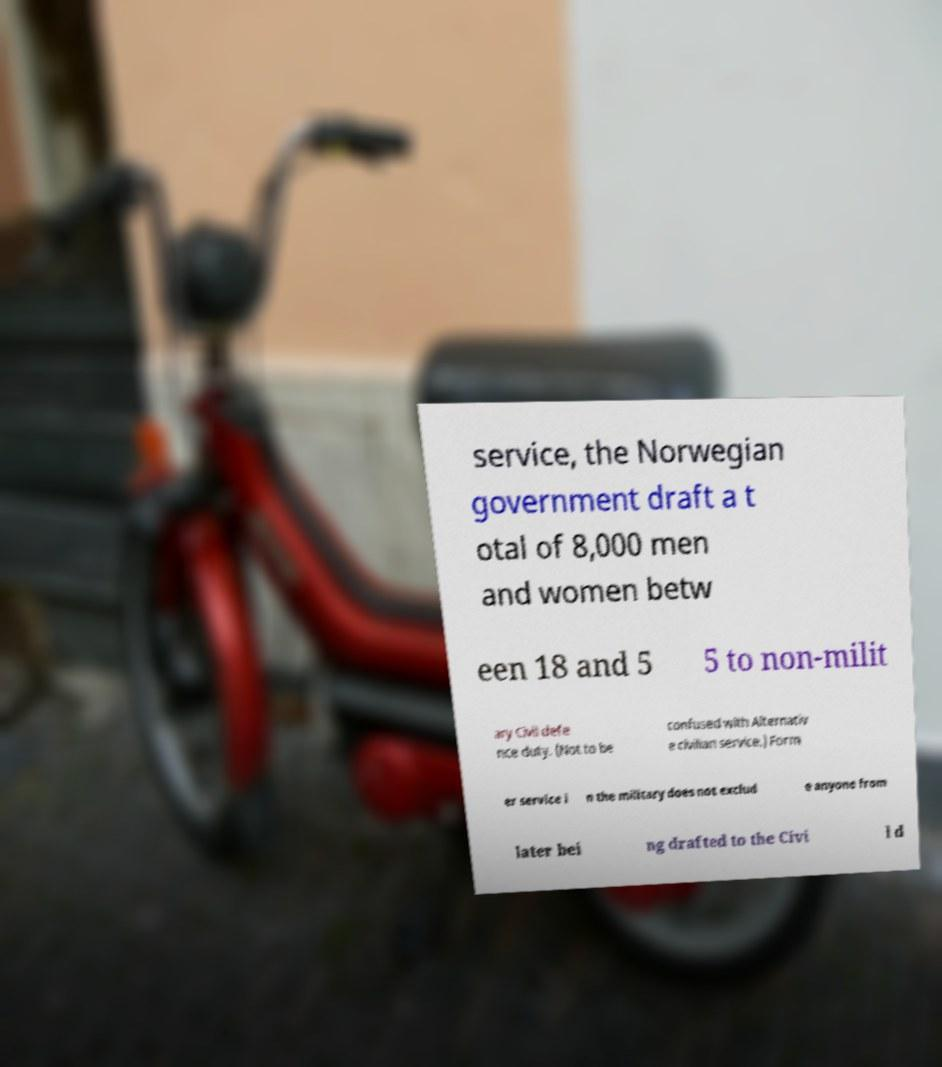Could you extract and type out the text from this image? service, the Norwegian government draft a t otal of 8,000 men and women betw een 18 and 5 5 to non-milit ary Civil defe nce duty. (Not to be confused with Alternativ e civilian service.) Form er service i n the military does not exclud e anyone from later bei ng drafted to the Civi l d 